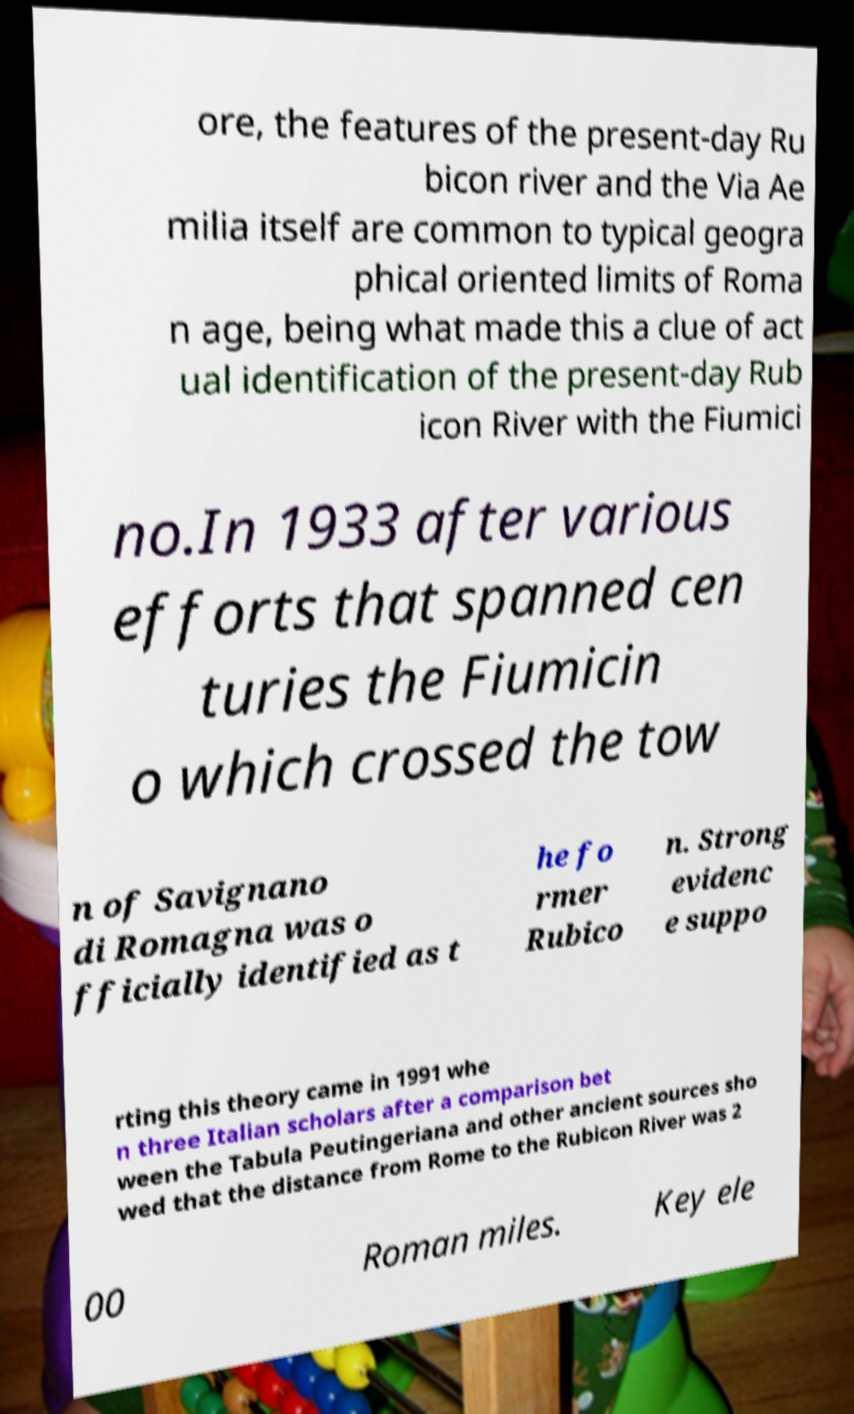What messages or text are displayed in this image? I need them in a readable, typed format. ore, the features of the present-day Ru bicon river and the Via Ae milia itself are common to typical geogra phical oriented limits of Roma n age, being what made this a clue of act ual identification of the present-day Rub icon River with the Fiumici no.In 1933 after various efforts that spanned cen turies the Fiumicin o which crossed the tow n of Savignano di Romagna was o fficially identified as t he fo rmer Rubico n. Strong evidenc e suppo rting this theory came in 1991 whe n three Italian scholars after a comparison bet ween the Tabula Peutingeriana and other ancient sources sho wed that the distance from Rome to the Rubicon River was 2 00 Roman miles. Key ele 